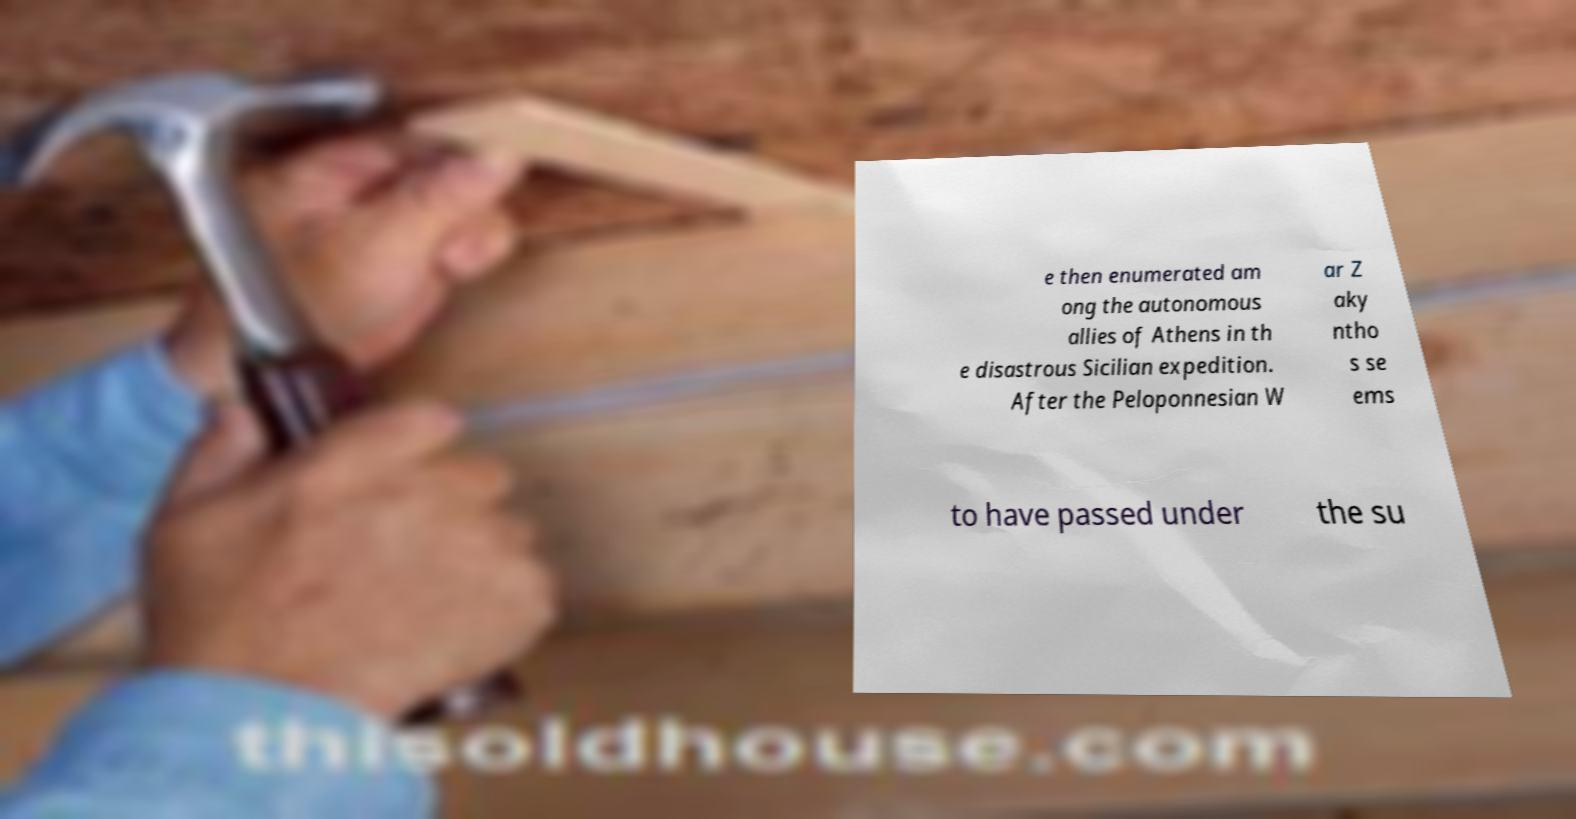Please read and relay the text visible in this image. What does it say? e then enumerated am ong the autonomous allies of Athens in th e disastrous Sicilian expedition. After the Peloponnesian W ar Z aky ntho s se ems to have passed under the su 